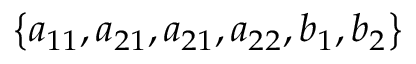Convert formula to latex. <formula><loc_0><loc_0><loc_500><loc_500>\left \{ { { a _ { 1 1 } } , { a _ { 2 1 } } , { a _ { 2 1 } } , { a _ { 2 2 } } , { b _ { 1 } } , { b _ { 2 } } } \right \}</formula> 